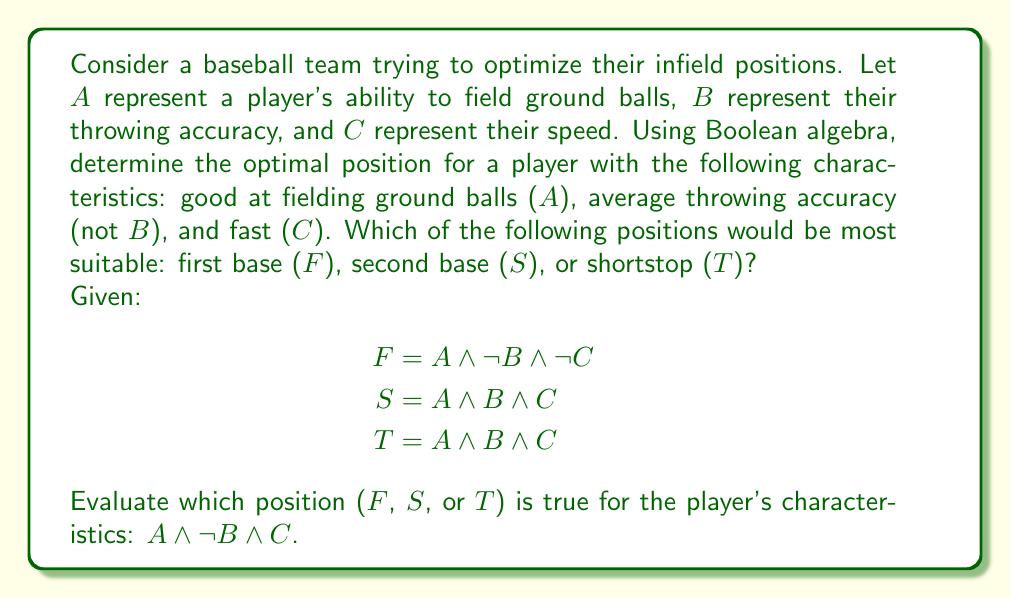What is the answer to this math problem? Let's evaluate each position using the given Boolean expressions and the player's characteristics (A ∧ ¬B ∧ C):

1. First base (F):
   F = A ∧ ¬B ∧ ¬C
   Substituting the player's characteristics:
   F = A ∧ ¬B ∧ ¬C
   F = 1 ∧ 1 ∧ 0 = 0

2. Second base (S):
   S = A ∧ B ∧ C
   Substituting the player's characteristics:
   S = A ∧ ¬B ∧ C
   S = 1 ∧ 0 ∧ 1 = 0

3. Shortstop (T):
   T = A ∧ B ∧ C
   Substituting the player's characteristics:
   T = A ∧ ¬B ∧ C
   T = 1 ∧ 0 ∧ 1 = 0

None of the given positions perfectly match the player's characteristics. However, we can determine the best fit by comparing the number of matching attributes:

First base (F): Matches 2 out of 3 attributes (A and ¬B)
Second base (S): Matches 2 out of 3 attributes (A and C)
Shortstop (T): Matches 2 out of 3 attributes (A and C)

Since both second base and shortstop match the same number of attributes and require speed (C), which the player possesses, either of these positions would be suitable. However, given that shortstop generally requires a stronger arm (B), which the player lacks, second base (S) would be the most optimal position for this player.
Answer: Second base (S) 